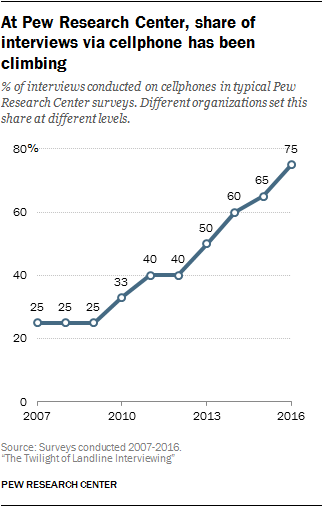Draw attention to some important aspects in this diagram. The median value of the graph is 40. The task is to find missing data based on a range of numbers provided. The missing data is represented by the numbers 25, 40, 50, and 60, and the numbers 33 is also provided. 